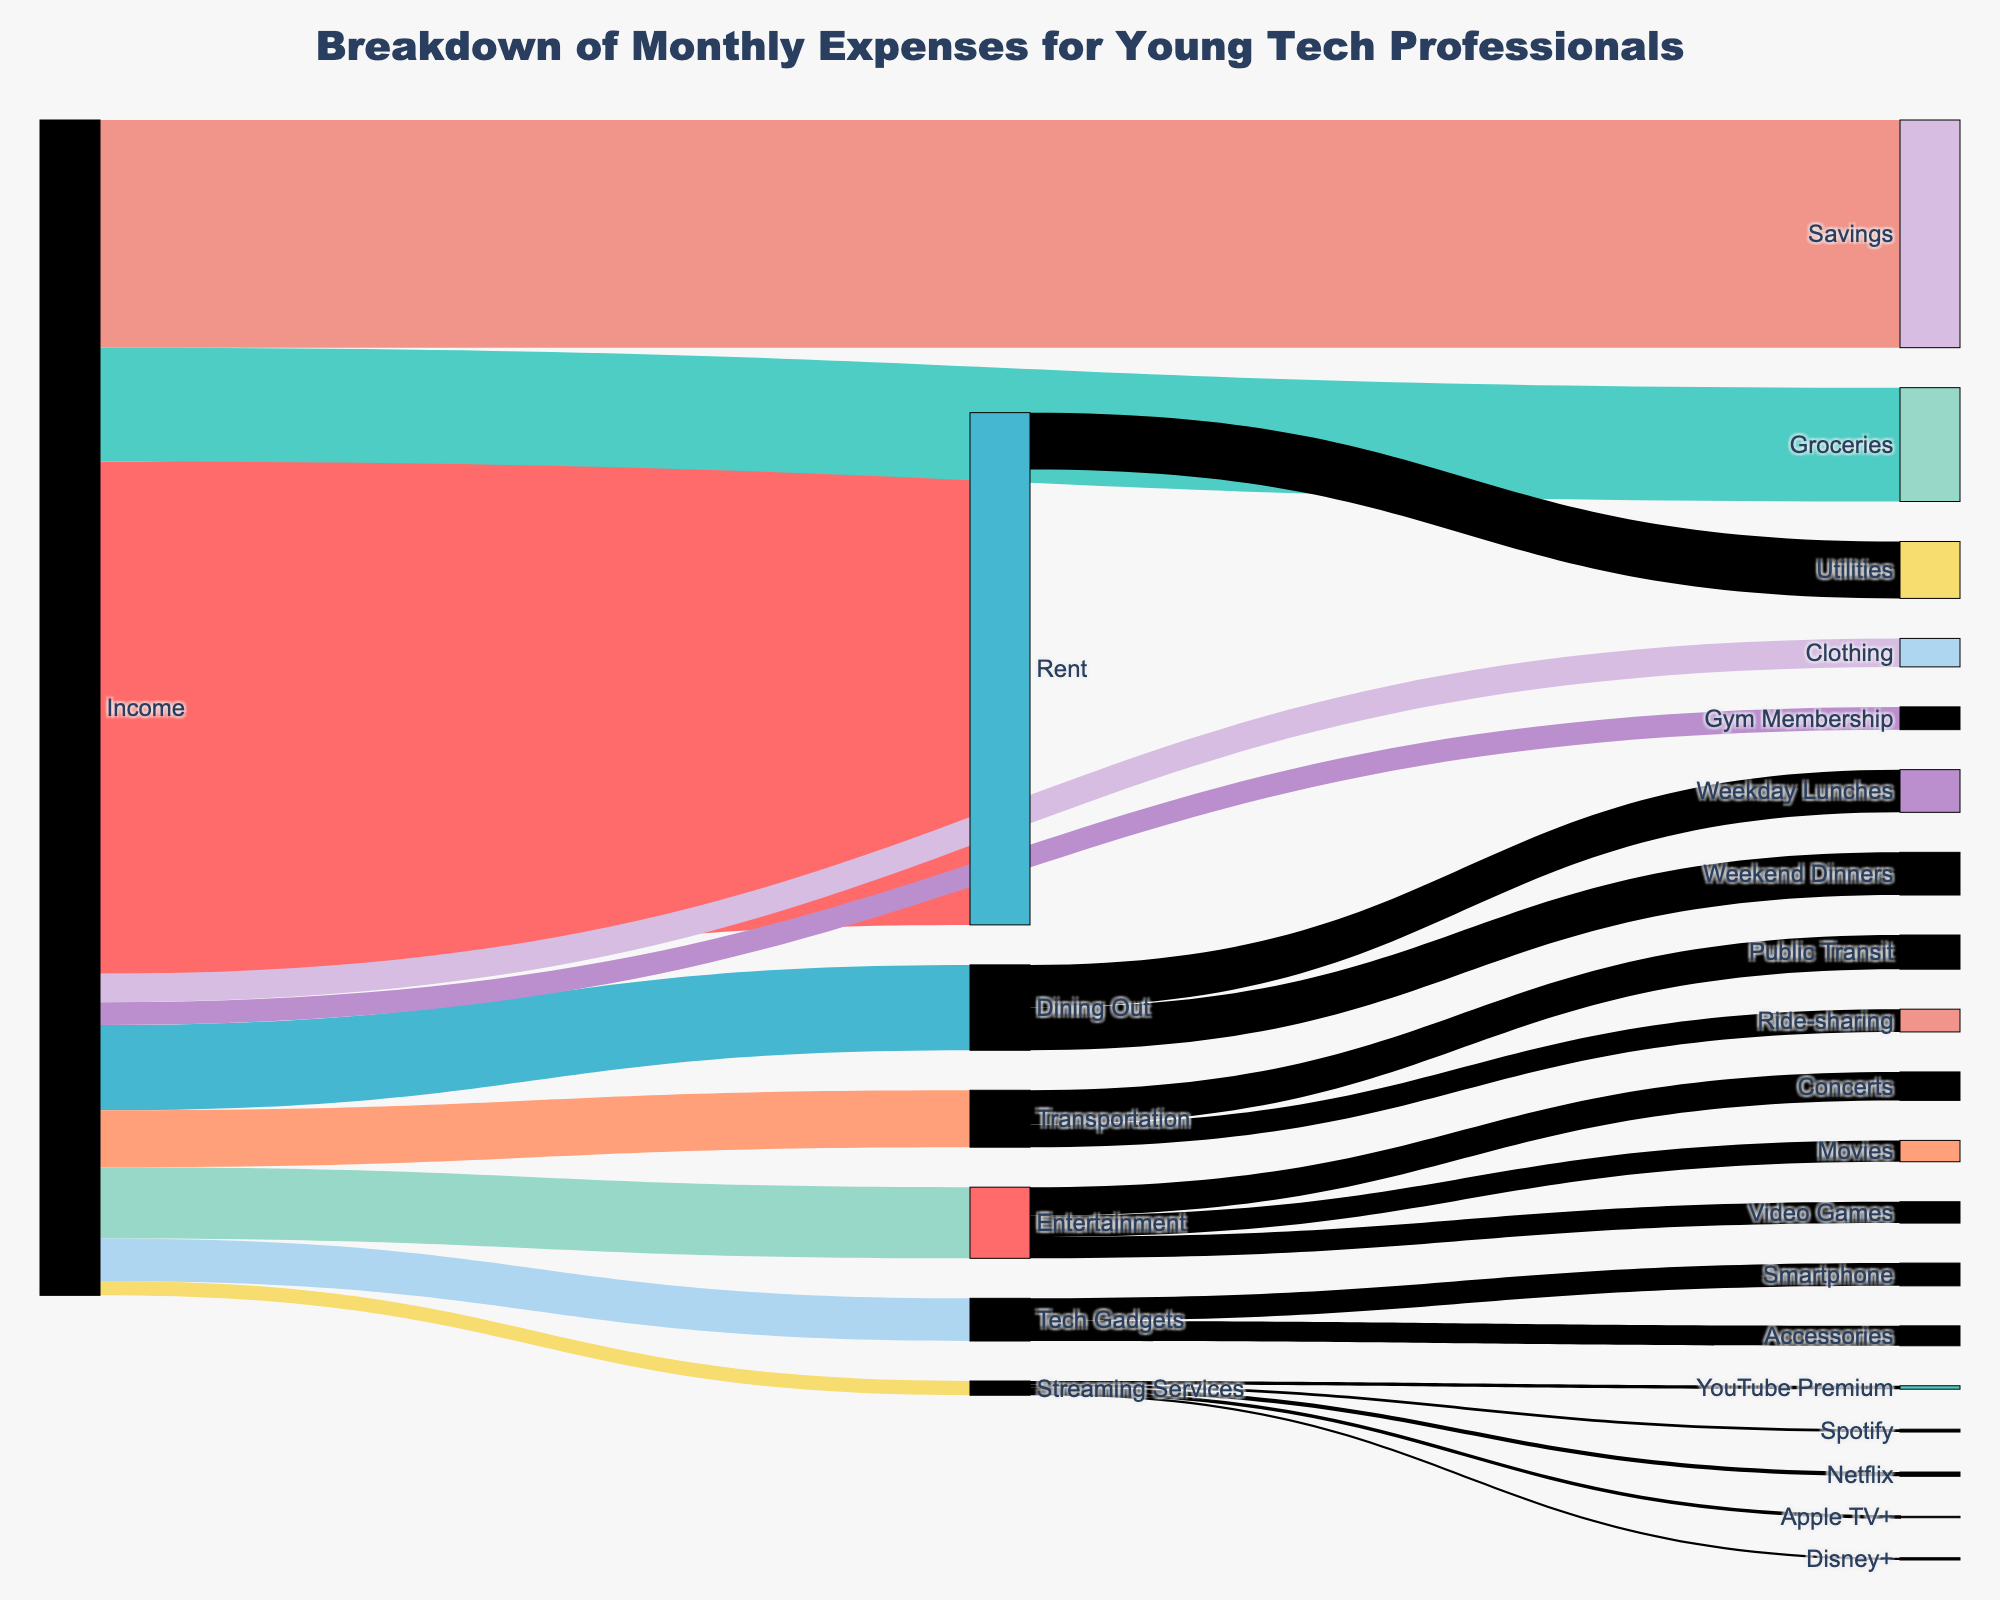What's the title of the figure? The title is typically found at the top of the figure in a larger font size.
Answer: Breakdown of Monthly Expenses for Young Tech Professionals How much money is allocated to Rent? By following the flow from the Income node to the Rent node, we can see the value corresponding to Rent.
Answer: 1800 Which category receives the least funding from Income? We compare the values connected directly from the Income source to their respective targets.
Answer: Streaming Services How much is spent on Gym Memberships monthly? By following the flow from the Income node to the Gym Membership node, we can see the value corresponding to Gym Membership.
Answer: 80 What's the total expenditure on Entertainment including movies, concerts, and video games? Add the individual values of Movies, Concerts, and Video Games to get the total expenditure on Entertainment.
Answer: 75 + 100 + 75 = 250 How does the spending on Savings compare to Transportation? Compare the values connected to the Savings and Transportation nodes from Income.
Answer: Savings is greater What's the combined expenditure on Dining Out and Groceries? Add the expenditures for Dining Out and Groceries.
Answer: 300 + 400 = 700 Which specific Streaming Service has the highest funding? Among the Streaming Services (Netflix, Spotify, Disney+, YouTube Premium, Apple TV+), identify the one with the highest value.
Answer: YouTube Premium What are the two categories that receive 150 each from Income? Identify the nodes that have a value of 150 connected from Income.
Answer: Tech Gadgets, Dining Out How much is spent on Public Transit and Ride-sharing combined monthly? Add the individual expenditures for Public Transit and Ride-sharing from Transportation.
Answer: 120 + 80 = 200 